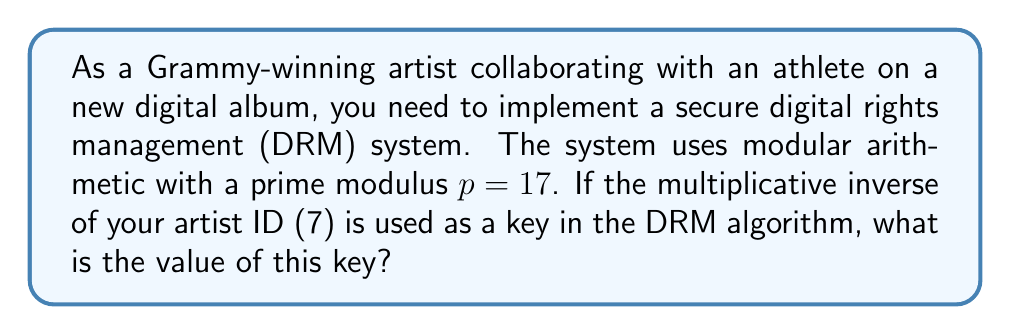Can you solve this math problem? To find the modular multiplicative inverse of 7 modulo 17, we need to find a number $x$ such that:

$$(7x) \equiv 1 \pmod{17}$$

We can use the extended Euclidean algorithm to find this value:

1) First, apply the Euclidean algorithm:
   $$17 = 2 \cdot 7 + 3$$
   $$7 = 2 \cdot 3 + 1$$
   $$3 = 3 \cdot 1 + 0$$

2) Now, work backwards to express 1 as a linear combination of 17 and 7:
   $$1 = 7 - 2 \cdot 3$$
   $$1 = 7 - 2 \cdot (17 - 2 \cdot 7)$$
   $$1 = 5 \cdot 7 - 2 \cdot 17$$

3) This means that $5 \cdot 7 \equiv 1 \pmod{17}$

4) Therefore, 5 is the modular multiplicative inverse of 7 modulo 17.

We can verify: $5 \cdot 7 = 35 \equiv 1 \pmod{17}$
Answer: 5 